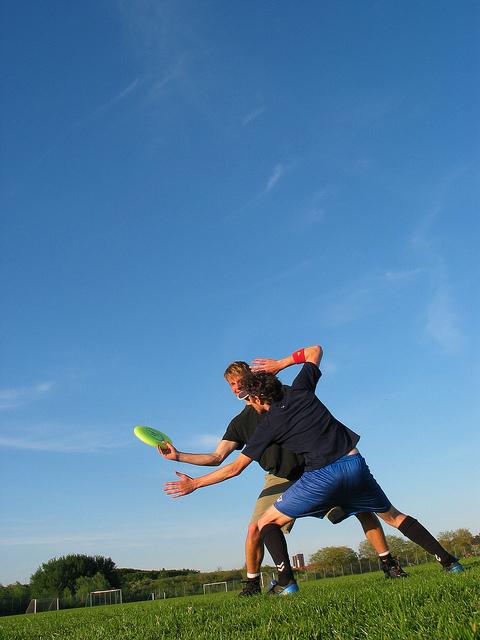Are the two men playing Frisbee?
Answer briefly. Yes. What color is the sky?
Answer briefly. Blue. Which man wears long socks?
Be succinct. Front. 